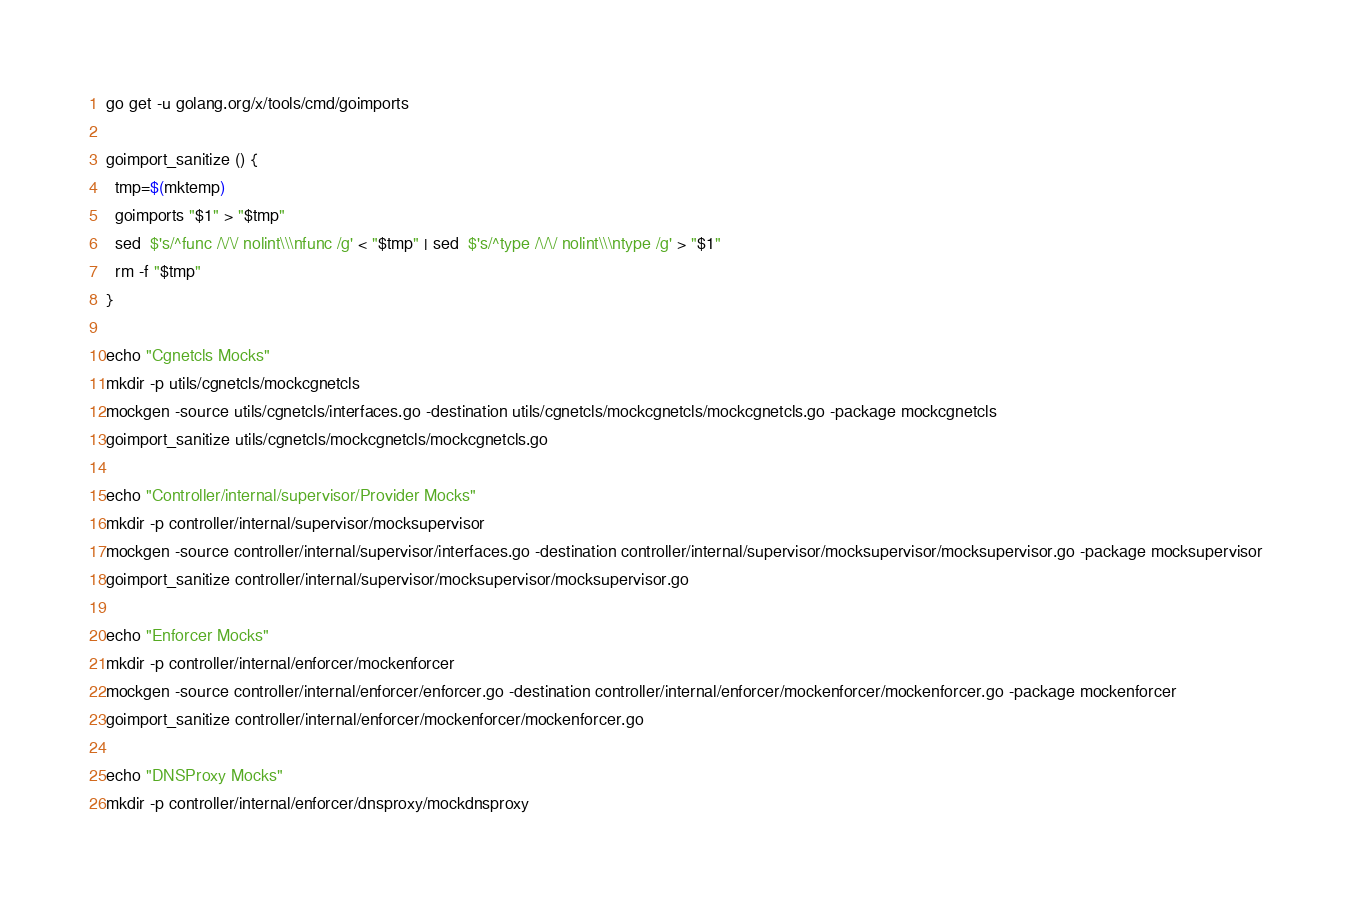<code> <loc_0><loc_0><loc_500><loc_500><_Bash_>go get -u golang.org/x/tools/cmd/goimports

goimport_sanitize () {
  tmp=$(mktemp)
  goimports "$1" > "$tmp"
  sed  $'s/^func /\/\/ nolint\\\nfunc /g' < "$tmp" | sed  $'s/^type /\/\/ nolint\\\ntype /g' > "$1"
  rm -f "$tmp"
}

echo "Cgnetcls Mocks"
mkdir -p utils/cgnetcls/mockcgnetcls
mockgen -source utils/cgnetcls/interfaces.go -destination utils/cgnetcls/mockcgnetcls/mockcgnetcls.go -package mockcgnetcls
goimport_sanitize utils/cgnetcls/mockcgnetcls/mockcgnetcls.go

echo "Controller/internal/supervisor/Provider Mocks"
mkdir -p controller/internal/supervisor/mocksupervisor
mockgen -source controller/internal/supervisor/interfaces.go -destination controller/internal/supervisor/mocksupervisor/mocksupervisor.go -package mocksupervisor
goimport_sanitize controller/internal/supervisor/mocksupervisor/mocksupervisor.go

echo "Enforcer Mocks"
mkdir -p controller/internal/enforcer/mockenforcer
mockgen -source controller/internal/enforcer/enforcer.go -destination controller/internal/enforcer/mockenforcer/mockenforcer.go -package mockenforcer
goimport_sanitize controller/internal/enforcer/mockenforcer/mockenforcer.go

echo "DNSProxy Mocks"
mkdir -p controller/internal/enforcer/dnsproxy/mockdnsproxy</code> 